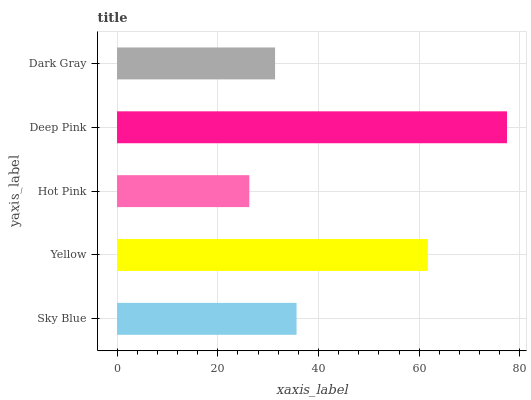Is Hot Pink the minimum?
Answer yes or no. Yes. Is Deep Pink the maximum?
Answer yes or no. Yes. Is Yellow the minimum?
Answer yes or no. No. Is Yellow the maximum?
Answer yes or no. No. Is Yellow greater than Sky Blue?
Answer yes or no. Yes. Is Sky Blue less than Yellow?
Answer yes or no. Yes. Is Sky Blue greater than Yellow?
Answer yes or no. No. Is Yellow less than Sky Blue?
Answer yes or no. No. Is Sky Blue the high median?
Answer yes or no. Yes. Is Sky Blue the low median?
Answer yes or no. Yes. Is Hot Pink the high median?
Answer yes or no. No. Is Dark Gray the low median?
Answer yes or no. No. 